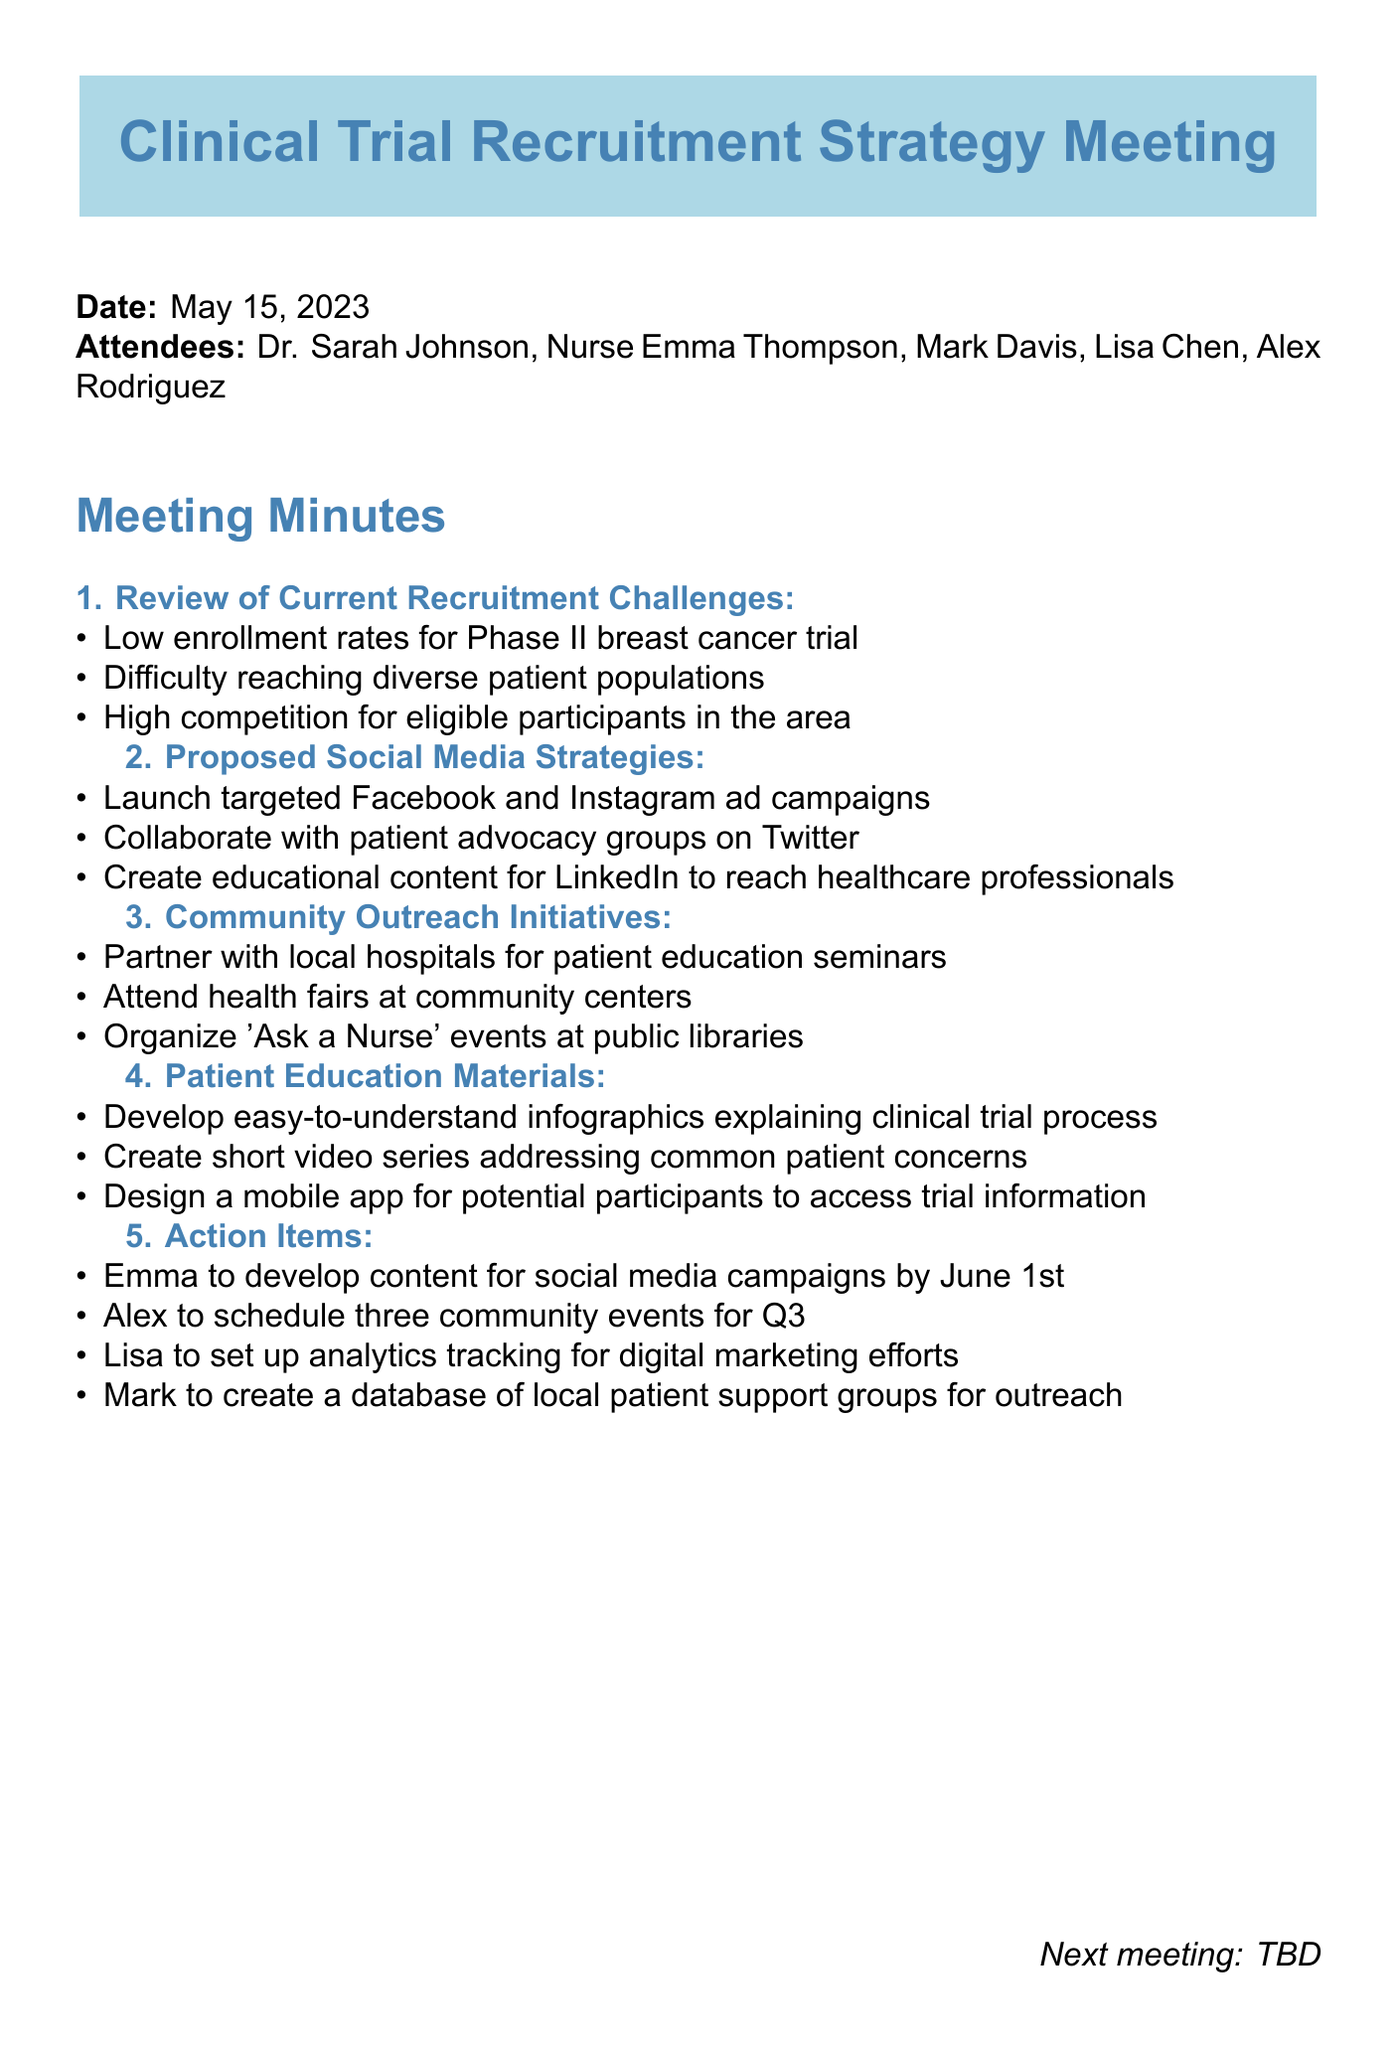What is the date of the meeting? The date of the meeting is explicitly mentioned in the document.
Answer: May 15, 2023 Who is the Community Outreach Manager? The document lists the attendees, including their roles, making it clear who holds each position.
Answer: Alex Rodriguez What is one challenge mentioned for patient recruitment? The meeting minutes highlight specific challenges in recruitment that were discussed, allowing for easy identification of issues.
Answer: Low enrollment rates for Phase II breast cancer trial What is one proposed social media strategy? The document outlines the strategies that were proposed during the meeting, providing a clear list of actions.
Answer: Launch targeted Facebook and Instagram ad campaigns How many community events are scheduled for Q3? The action items detail specific plans for community outreach, including the number of planned events.
Answer: Three Which nurse is responsible for developing content for social media campaigns? The action items specify who is responsible for each task, making it easy to identify accountability.
Answer: Emma What type of educational content is to be created for LinkedIn? Proposed social media strategies include specific content types aimed at different audiences, providing clarity on objectives.
Answer: Educational content for healthcare professionals What is one patient education material to be developed? The document details specific educational materials proposed for patient understanding of clinical trials.
Answer: Infographics explaining clinical trial process 